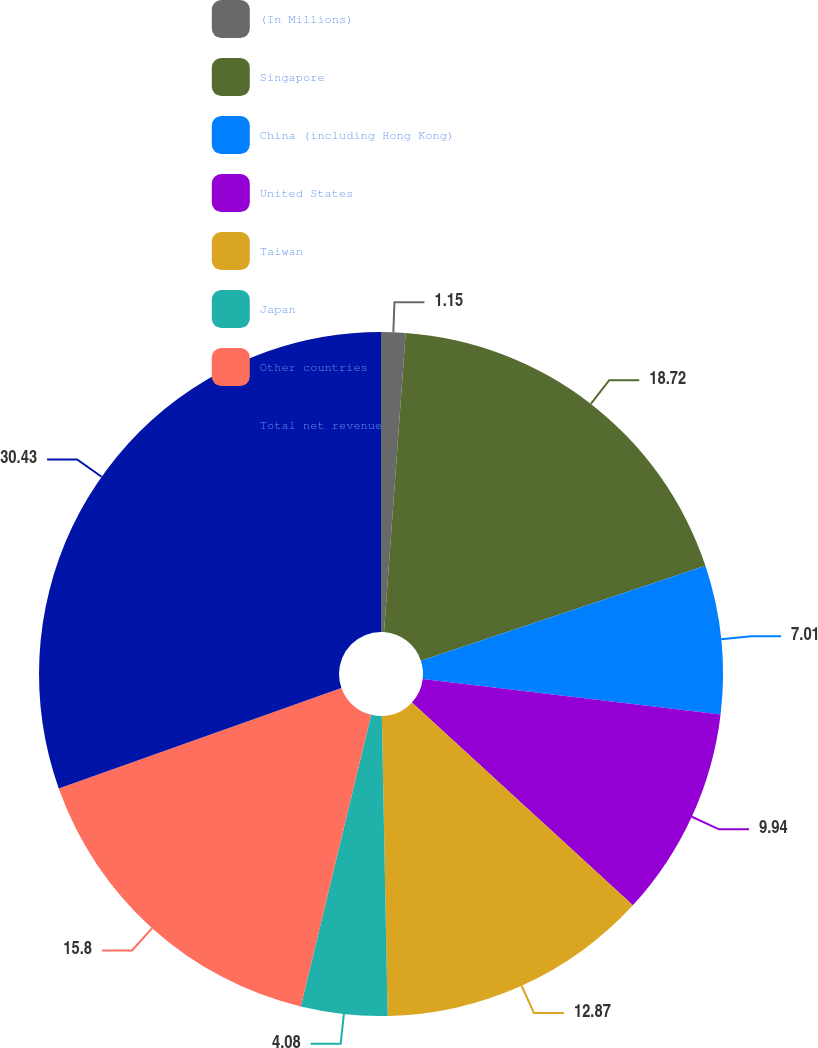Convert chart to OTSL. <chart><loc_0><loc_0><loc_500><loc_500><pie_chart><fcel>(In Millions)<fcel>Singapore<fcel>China (including Hong Kong)<fcel>United States<fcel>Taiwan<fcel>Japan<fcel>Other countries<fcel>Total net revenue<nl><fcel>1.15%<fcel>18.73%<fcel>7.01%<fcel>9.94%<fcel>12.87%<fcel>4.08%<fcel>15.8%<fcel>30.44%<nl></chart> 